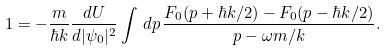<formula> <loc_0><loc_0><loc_500><loc_500>1 = - \frac { m } { \hbar { k } } \frac { d U } { d | \psi _ { 0 } | ^ { 2 } } \int \, d p \, \frac { F _ { 0 } ( p + \hbar { k } / 2 ) - F _ { 0 } ( p - \hbar { k } / 2 ) } { p - \omega m / k } .</formula> 